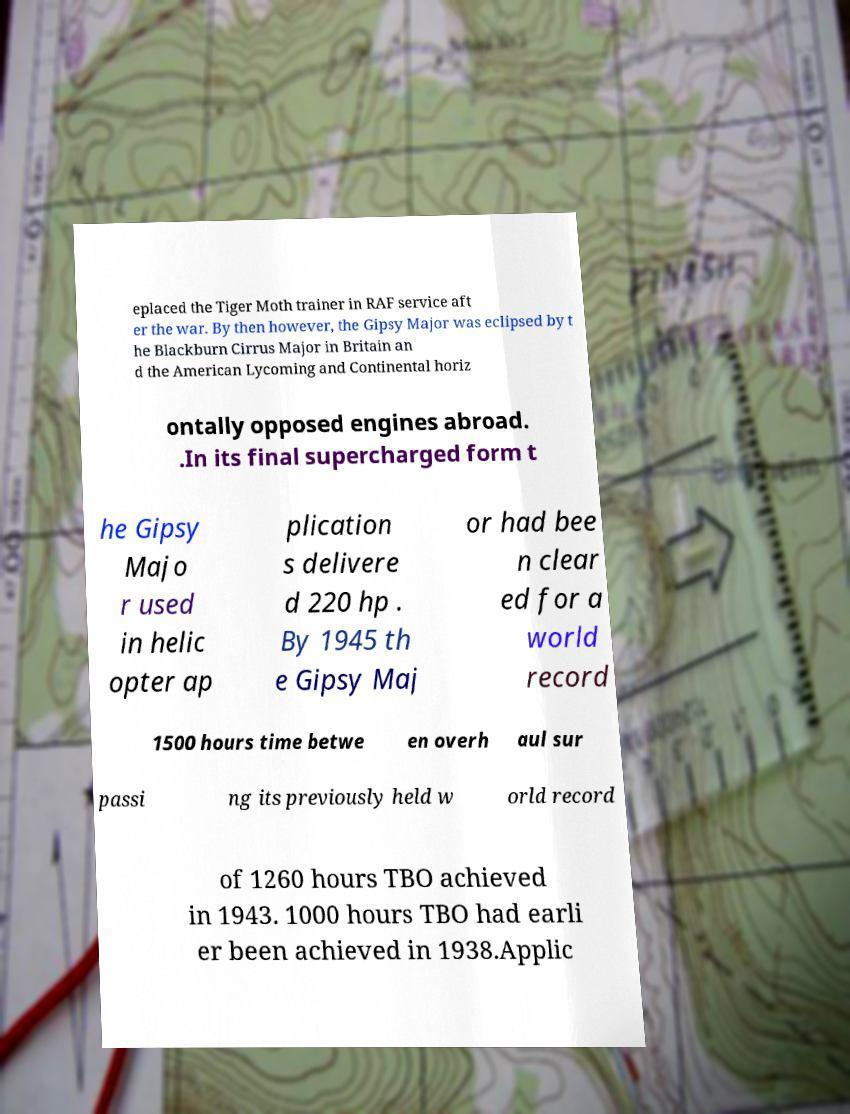Please identify and transcribe the text found in this image. eplaced the Tiger Moth trainer in RAF service aft er the war. By then however, the Gipsy Major was eclipsed by t he Blackburn Cirrus Major in Britain an d the American Lycoming and Continental horiz ontally opposed engines abroad. .In its final supercharged form t he Gipsy Majo r used in helic opter ap plication s delivere d 220 hp . By 1945 th e Gipsy Maj or had bee n clear ed for a world record 1500 hours time betwe en overh aul sur passi ng its previously held w orld record of 1260 hours TBO achieved in 1943. 1000 hours TBO had earli er been achieved in 1938.Applic 